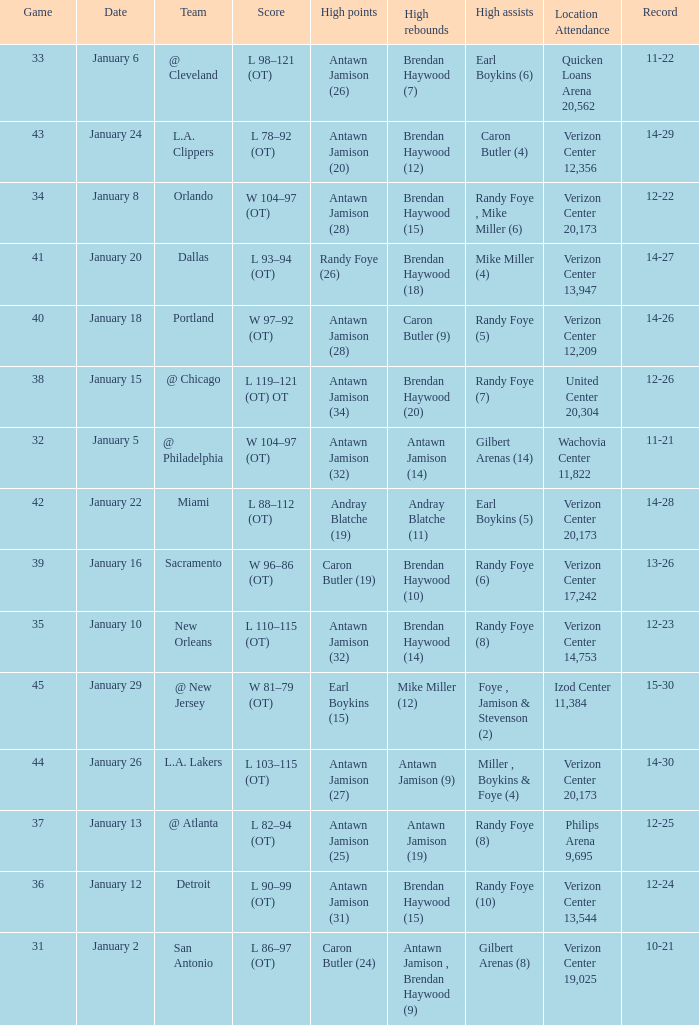How many people got high points in game 35? 1.0. 